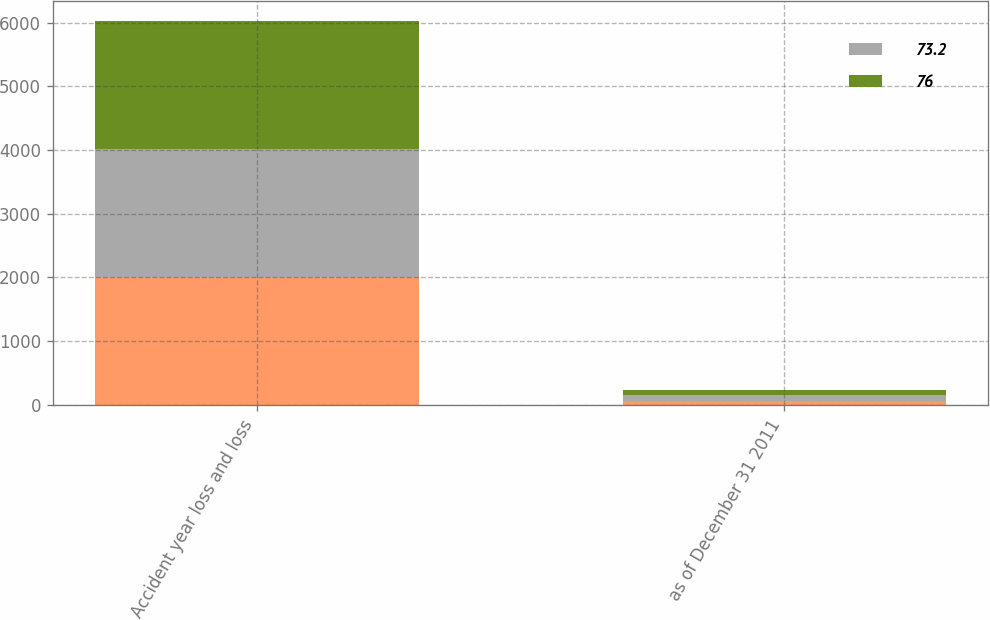Convert chart to OTSL. <chart><loc_0><loc_0><loc_500><loc_500><stacked_bar_chart><ecel><fcel>Accident year loss and loss<fcel>as of December 31 2011<nl><fcel>nan<fcel>2011<fcel>65<nl><fcel>73.2<fcel>2009<fcel>89<nl><fcel>76<fcel>2009<fcel>85.6<nl></chart> 